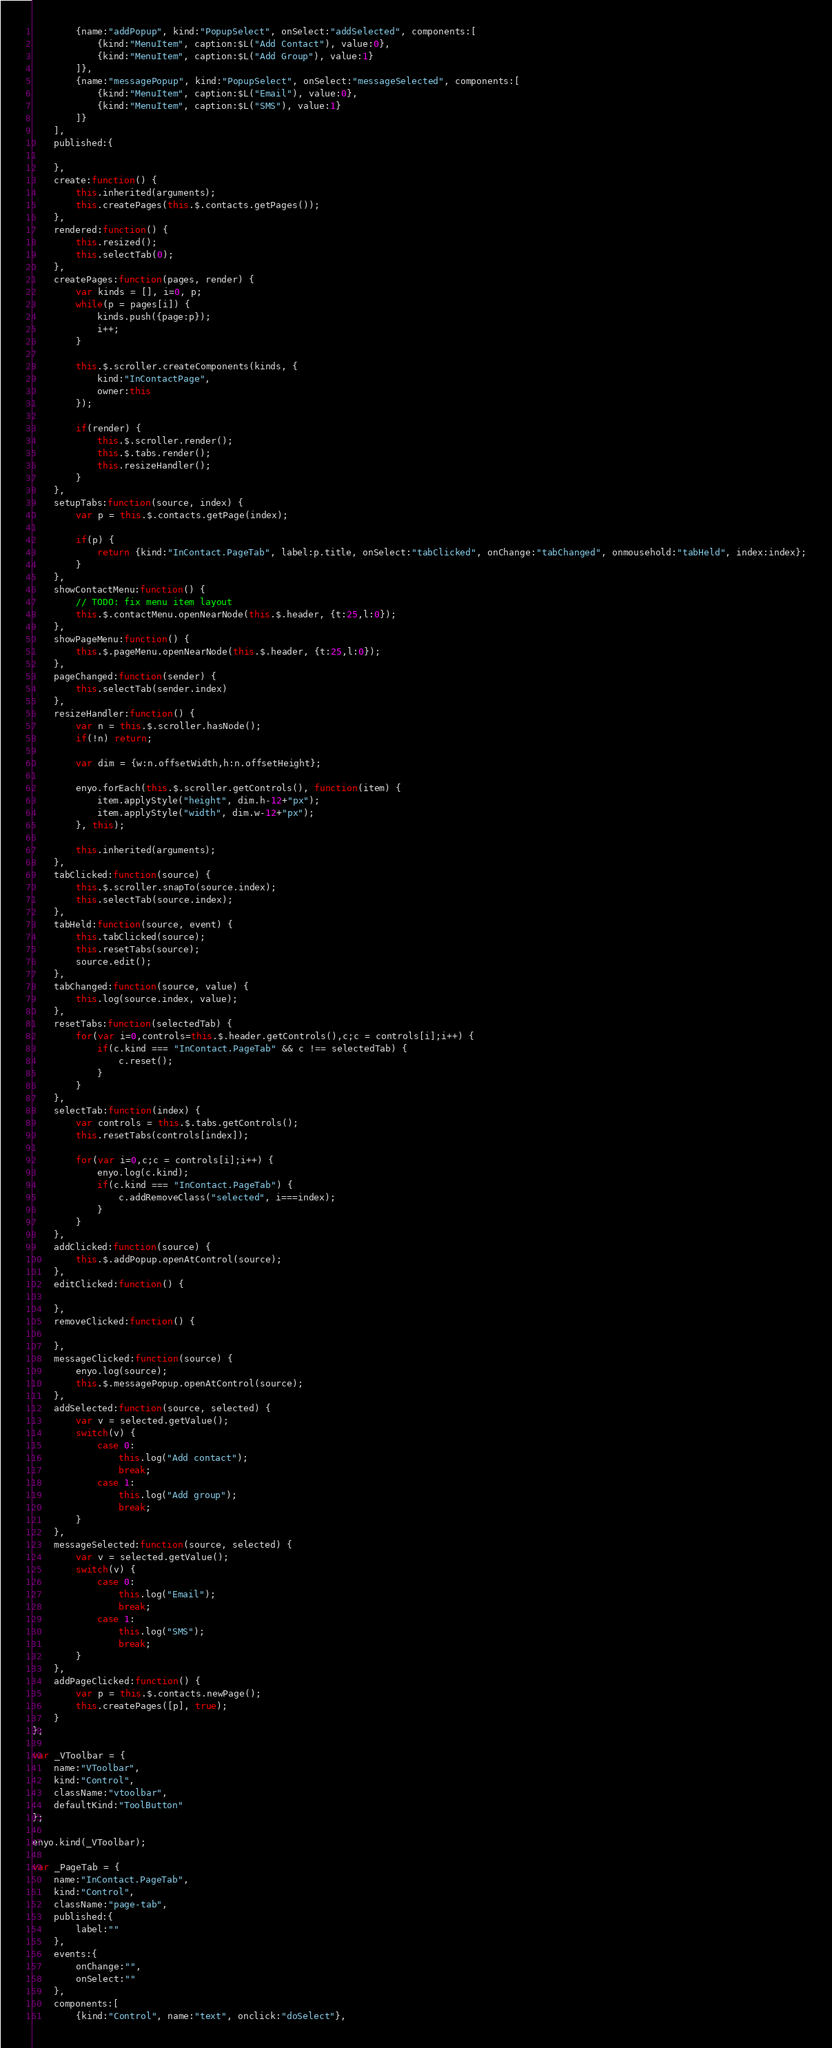Convert code to text. <code><loc_0><loc_0><loc_500><loc_500><_JavaScript_>		{name:"addPopup", kind:"PopupSelect", onSelect:"addSelected", components:[
            {kind:"MenuItem", caption:$L("Add Contact"), value:0},
            {kind:"MenuItem", caption:$L("Add Group"), value:1}
        ]},
        {name:"messagePopup", kind:"PopupSelect", onSelect:"messageSelected", components:[
            {kind:"MenuItem", caption:$L("Email"), value:0},
            {kind:"MenuItem", caption:$L("SMS"), value:1}
        ]}
	],
	published:{

	},
	create:function() {
		this.inherited(arguments);
		this.createPages(this.$.contacts.getPages());
	},
	rendered:function() {
		this.resized();
		this.selectTab(0);
	},
	createPages:function(pages, render) {
		var kinds = [], i=0, p;
		while(p = pages[i]) {
			kinds.push({page:p});
			i++;
		}
		
		this.$.scroller.createComponents(kinds, {
			kind:"InContactPage",
			owner:this
		});
		
		if(render) {
			this.$.scroller.render();
			this.$.tabs.render();
			this.resizeHandler();
		}
	},
	setupTabs:function(source, index) {
		var p = this.$.contacts.getPage(index);
		
		if(p) {
			return {kind:"InContact.PageTab", label:p.title, onSelect:"tabClicked", onChange:"tabChanged", onmousehold:"tabHeld", index:index};
		}
	},
	showContactMenu:function() {
		// TODO: fix menu item layout
		this.$.contactMenu.openNearNode(this.$.header, {t:25,l:0});
	},
	showPageMenu:function() {
		this.$.pageMenu.openNearNode(this.$.header, {t:25,l:0});
	},
	pageChanged:function(sender) {
		this.selectTab(sender.index)
	},
	resizeHandler:function() {
		var n = this.$.scroller.hasNode();
		if(!n) return;
		
		var dim = {w:n.offsetWidth,h:n.offsetHeight};
		
		enyo.forEach(this.$.scroller.getControls(), function(item) {
			item.applyStyle("height", dim.h-12+"px");
			item.applyStyle("width", dim.w-12+"px");
		}, this);
		
		this.inherited(arguments);
	},
	tabClicked:function(source) {
		this.$.scroller.snapTo(source.index);
		this.selectTab(source.index);
	},
	tabHeld:function(source, event) {
		this.tabClicked(source);
		this.resetTabs(source);
		source.edit();
	},
	tabChanged:function(source, value) {
		this.log(source.index, value);
	},
	resetTabs:function(selectedTab) {
		for(var i=0,controls=this.$.header.getControls(),c;c = controls[i];i++) {
			if(c.kind === "InContact.PageTab" && c !== selectedTab) {
				c.reset();
			}
		}
	},
	selectTab:function(index) {
		var controls = this.$.tabs.getControls();
		this.resetTabs(controls[index]);
		
		for(var i=0,c;c = controls[i];i++) {
			enyo.log(c.kind);
			if(c.kind === "InContact.PageTab") {
				c.addRemoveClass("selected", i===index);
			}
		}
	},
	addClicked:function(source) {
		this.$.addPopup.openAtControl(source);
	},
	editClicked:function() {
		
	},
	removeClicked:function() {
		
	},
	messageClicked:function(source) {
		enyo.log(source);
		this.$.messagePopup.openAtControl(source);
	},
	addSelected:function(source, selected) {
		var v = selected.getValue();
		switch(v) {
			case 0:
				this.log("Add contact");
				break;
			case 1:
				this.log("Add group");
				break;
		}
	},
	messageSelected:function(source, selected) {
		var v = selected.getValue();
		switch(v) {
			case 0:
				this.log("Email");
				break;
			case 1:
				this.log("SMS");
				break;
		}
	},
    addPageClicked:function() {
    	var p = this.$.contacts.newPage();
    	this.createPages([p], true);
    }
};

var _VToolbar = {
	name:"VToolbar",
	kind:"Control",
	className:"vtoolbar",
	defaultKind:"ToolButton"
};

enyo.kind(_VToolbar);

var _PageTab = {
	name:"InContact.PageTab",
	kind:"Control",
	className:"page-tab",
	published:{
		label:""
	},
	events:{
		onChange:"",
		onSelect:""
	},
	components:[
	    {kind:"Control", name:"text", onclick:"doSelect"},</code> 